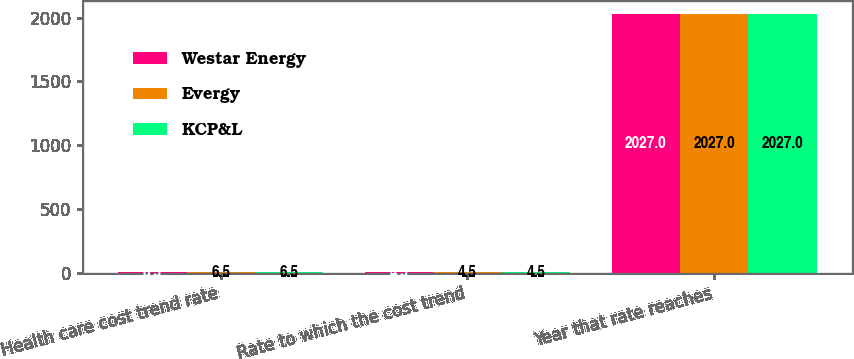Convert chart. <chart><loc_0><loc_0><loc_500><loc_500><stacked_bar_chart><ecel><fcel>Health care cost trend rate<fcel>Rate to which the cost trend<fcel>Year that rate reaches<nl><fcel>Westar Energy<fcel>6.5<fcel>4.5<fcel>2027<nl><fcel>Evergy<fcel>6.5<fcel>4.5<fcel>2027<nl><fcel>KCP&L<fcel>6.5<fcel>4.5<fcel>2027<nl></chart> 